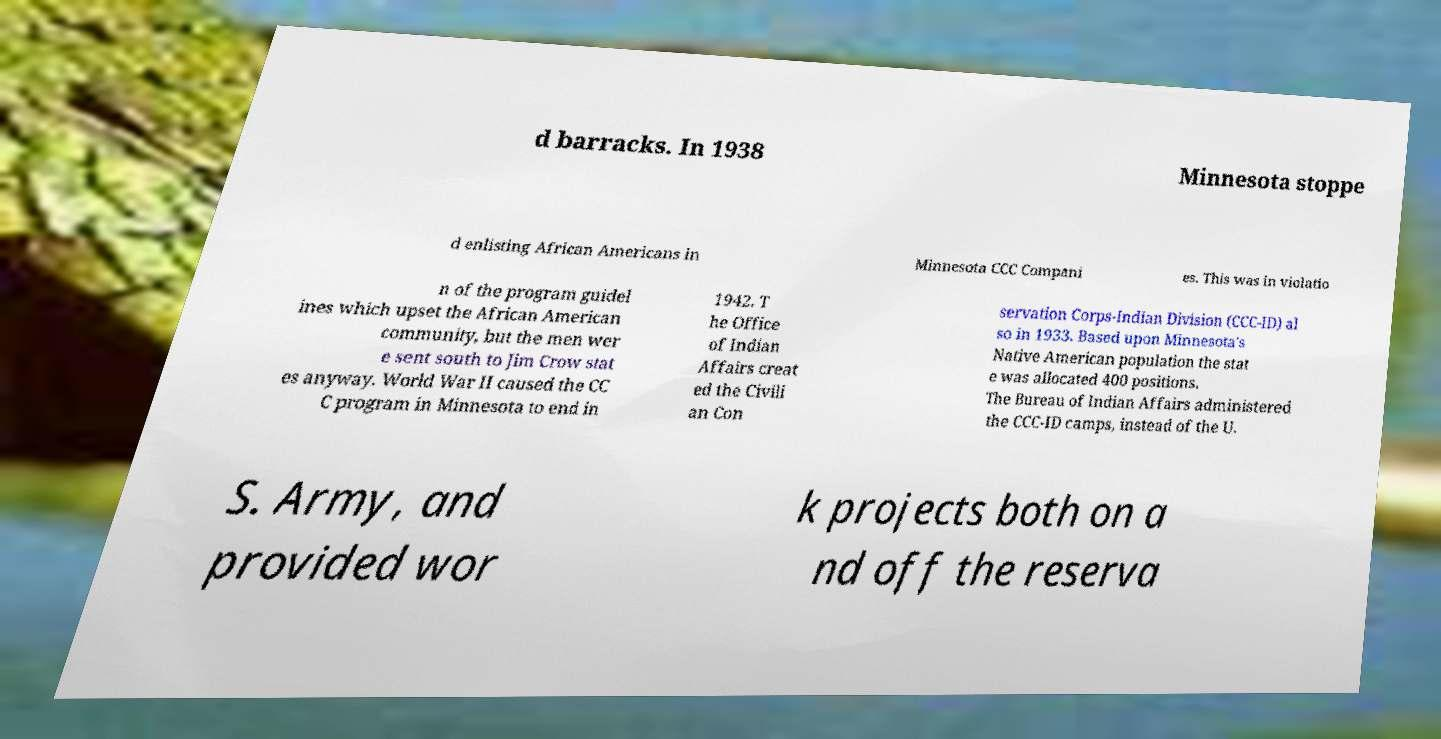Can you read and provide the text displayed in the image?This photo seems to have some interesting text. Can you extract and type it out for me? d barracks. In 1938 Minnesota stoppe d enlisting African Americans in Minnesota CCC Compani es. This was in violatio n of the program guidel ines which upset the African American community, but the men wer e sent south to Jim Crow stat es anyway. World War II caused the CC C program in Minnesota to end in 1942. T he Office of Indian Affairs creat ed the Civili an Con servation Corps-Indian Division (CCC-ID) al so in 1933. Based upon Minnesota's Native American population the stat e was allocated 400 positions. The Bureau of Indian Affairs administered the CCC-ID camps, instead of the U. S. Army, and provided wor k projects both on a nd off the reserva 